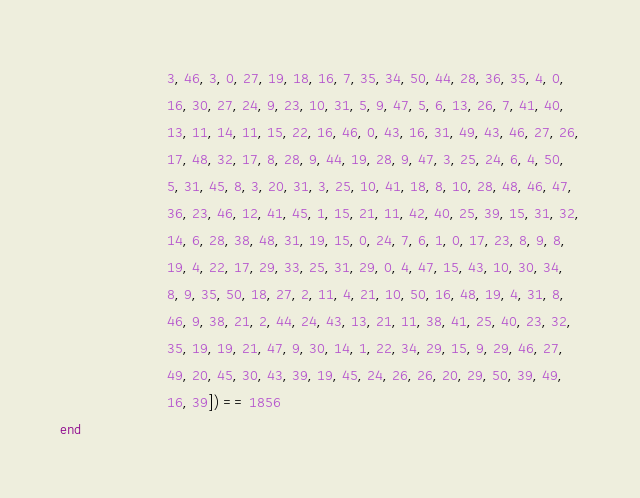<code> <loc_0><loc_0><loc_500><loc_500><_Julia_>                          3, 46, 3, 0, 27, 19, 18, 16, 7, 35, 34, 50, 44, 28, 36, 35, 4, 0,
                          16, 30, 27, 24, 9, 23, 10, 31, 5, 9, 47, 5, 6, 13, 26, 7, 41, 40,
                          13, 11, 14, 11, 15, 22, 16, 46, 0, 43, 16, 31, 49, 43, 46, 27, 26,
                          17, 48, 32, 17, 8, 28, 9, 44, 19, 28, 9, 47, 3, 25, 24, 6, 4, 50,
                          5, 31, 45, 8, 3, 20, 31, 3, 25, 10, 41, 18, 8, 10, 28, 48, 46, 47,
                          36, 23, 46, 12, 41, 45, 1, 15, 21, 11, 42, 40, 25, 39, 15, 31, 32,
                          14, 6, 28, 38, 48, 31, 19, 15, 0, 24, 7, 6, 1, 0, 17, 23, 8, 9, 8,
                          19, 4, 22, 17, 29, 33, 25, 31, 29, 0, 4, 47, 15, 43, 10, 30, 34,
                          8, 9, 35, 50, 18, 27, 2, 11, 4, 21, 10, 50, 16, 48, 19, 4, 31, 8,
                          46, 9, 38, 21, 2, 44, 24, 43, 13, 21, 11, 38, 41, 25, 40, 23, 32,
                          35, 19, 19, 21, 47, 9, 30, 14, 1, 22, 34, 29, 15, 9, 29, 46, 27,
                          49, 20, 45, 30, 43, 39, 19, 45, 24, 26, 26, 20, 29, 50, 39, 49,
                          16, 39]) == 1856
end
</code> 